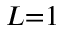<formula> <loc_0><loc_0><loc_500><loc_500>L { = } 1</formula> 